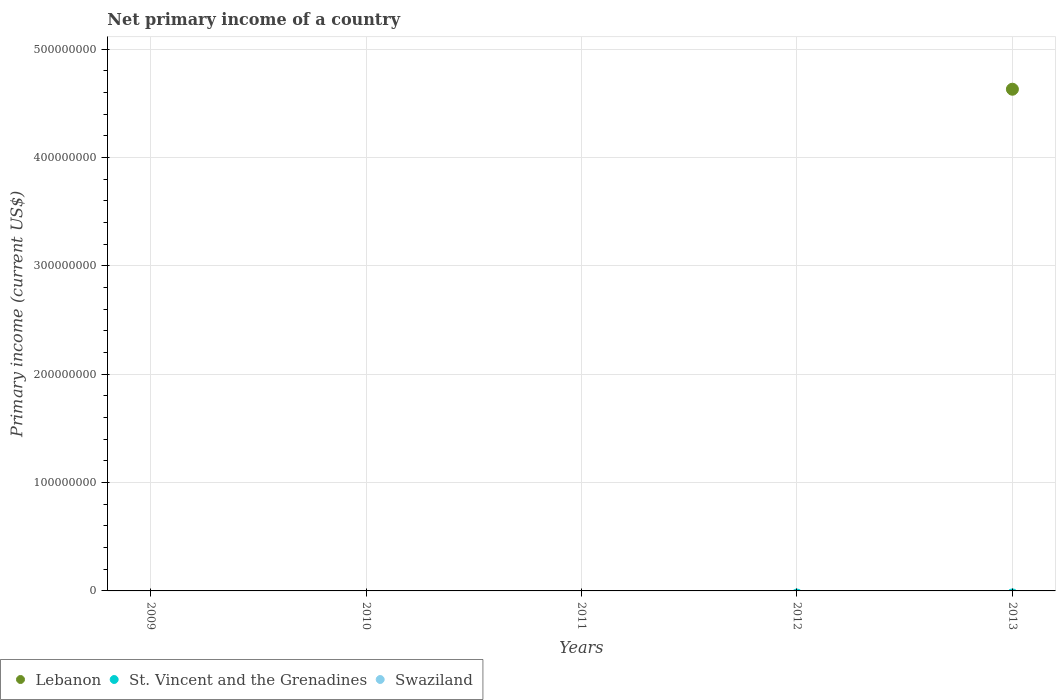How many different coloured dotlines are there?
Provide a succinct answer. 1. Across all years, what is the maximum primary income in Lebanon?
Your answer should be very brief. 4.63e+08. In which year was the primary income in Lebanon maximum?
Keep it short and to the point. 2013. What is the total primary income in Lebanon in the graph?
Your answer should be compact. 4.63e+08. What is the difference between the primary income in Lebanon in 2013 and the primary income in Swaziland in 2012?
Offer a very short reply. 4.63e+08. What is the average primary income in St. Vincent and the Grenadines per year?
Your response must be concise. 0. What is the difference between the highest and the lowest primary income in Lebanon?
Your response must be concise. 4.63e+08. In how many years, is the primary income in Lebanon greater than the average primary income in Lebanon taken over all years?
Provide a short and direct response. 1. Is it the case that in every year, the sum of the primary income in Swaziland and primary income in Lebanon  is greater than the primary income in St. Vincent and the Grenadines?
Provide a succinct answer. No. Does the primary income in St. Vincent and the Grenadines monotonically increase over the years?
Keep it short and to the point. No. Is the primary income in Lebanon strictly greater than the primary income in Swaziland over the years?
Your answer should be compact. No. Is the primary income in St. Vincent and the Grenadines strictly less than the primary income in Swaziland over the years?
Give a very brief answer. No. How many dotlines are there?
Offer a very short reply. 1. How many years are there in the graph?
Your answer should be compact. 5. Does the graph contain any zero values?
Keep it short and to the point. Yes. Does the graph contain grids?
Offer a very short reply. Yes. How are the legend labels stacked?
Give a very brief answer. Horizontal. What is the title of the graph?
Make the answer very short. Net primary income of a country. Does "Bulgaria" appear as one of the legend labels in the graph?
Your answer should be very brief. No. What is the label or title of the X-axis?
Provide a short and direct response. Years. What is the label or title of the Y-axis?
Your answer should be very brief. Primary income (current US$). What is the Primary income (current US$) in Lebanon in 2009?
Offer a terse response. 0. What is the Primary income (current US$) of St. Vincent and the Grenadines in 2009?
Your answer should be very brief. 0. What is the Primary income (current US$) in Lebanon in 2010?
Provide a succinct answer. 0. What is the Primary income (current US$) of Swaziland in 2010?
Provide a succinct answer. 0. What is the Primary income (current US$) of Lebanon in 2012?
Provide a short and direct response. 0. What is the Primary income (current US$) of St. Vincent and the Grenadines in 2012?
Make the answer very short. 0. What is the Primary income (current US$) of Swaziland in 2012?
Provide a short and direct response. 0. What is the Primary income (current US$) in Lebanon in 2013?
Provide a succinct answer. 4.63e+08. What is the Primary income (current US$) in Swaziland in 2013?
Make the answer very short. 0. Across all years, what is the maximum Primary income (current US$) of Lebanon?
Provide a short and direct response. 4.63e+08. Across all years, what is the minimum Primary income (current US$) in Lebanon?
Make the answer very short. 0. What is the total Primary income (current US$) of Lebanon in the graph?
Provide a short and direct response. 4.63e+08. What is the total Primary income (current US$) of Swaziland in the graph?
Keep it short and to the point. 0. What is the average Primary income (current US$) in Lebanon per year?
Make the answer very short. 9.26e+07. What is the average Primary income (current US$) of St. Vincent and the Grenadines per year?
Your answer should be compact. 0. What is the average Primary income (current US$) of Swaziland per year?
Provide a succinct answer. 0. What is the difference between the highest and the lowest Primary income (current US$) of Lebanon?
Provide a succinct answer. 4.63e+08. 